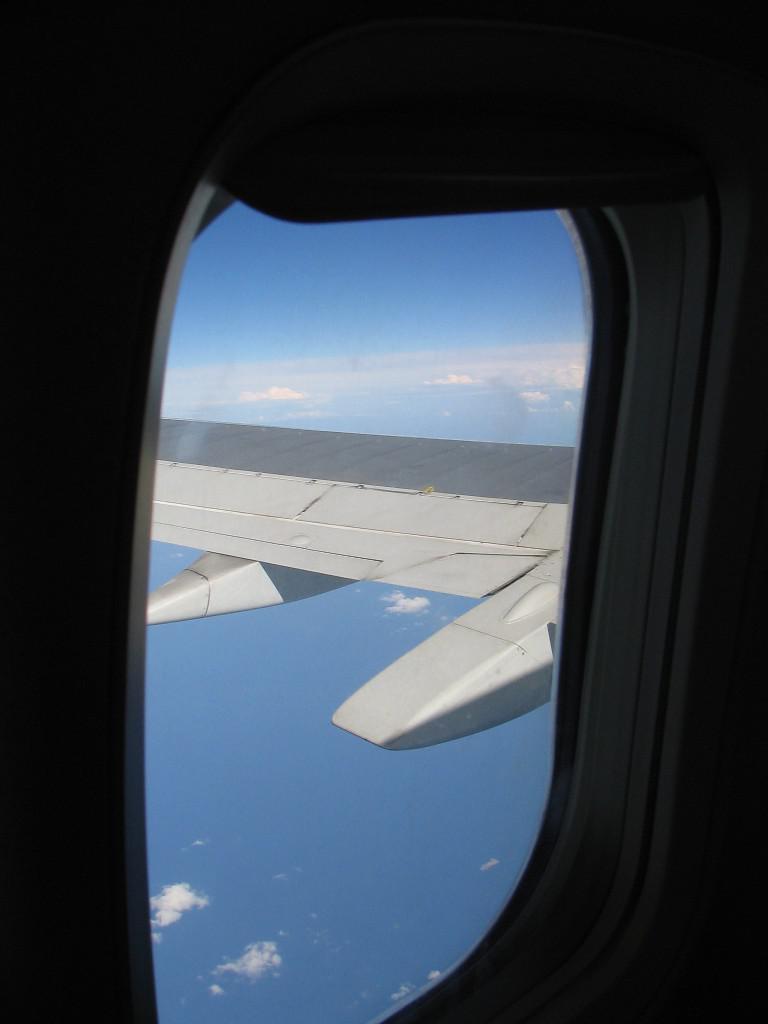Describe this image in one or two sentences. In this image we can see window of a flight. Through the window we can see the wing of the flight. And there is sky with clouds. 